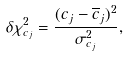<formula> <loc_0><loc_0><loc_500><loc_500>\delta \chi _ { c _ { j } } ^ { 2 } = \frac { ( c _ { j } - \overline { c } _ { j } ) ^ { 2 } } { \sigma _ { c _ { j } } ^ { 2 } } ,</formula> 